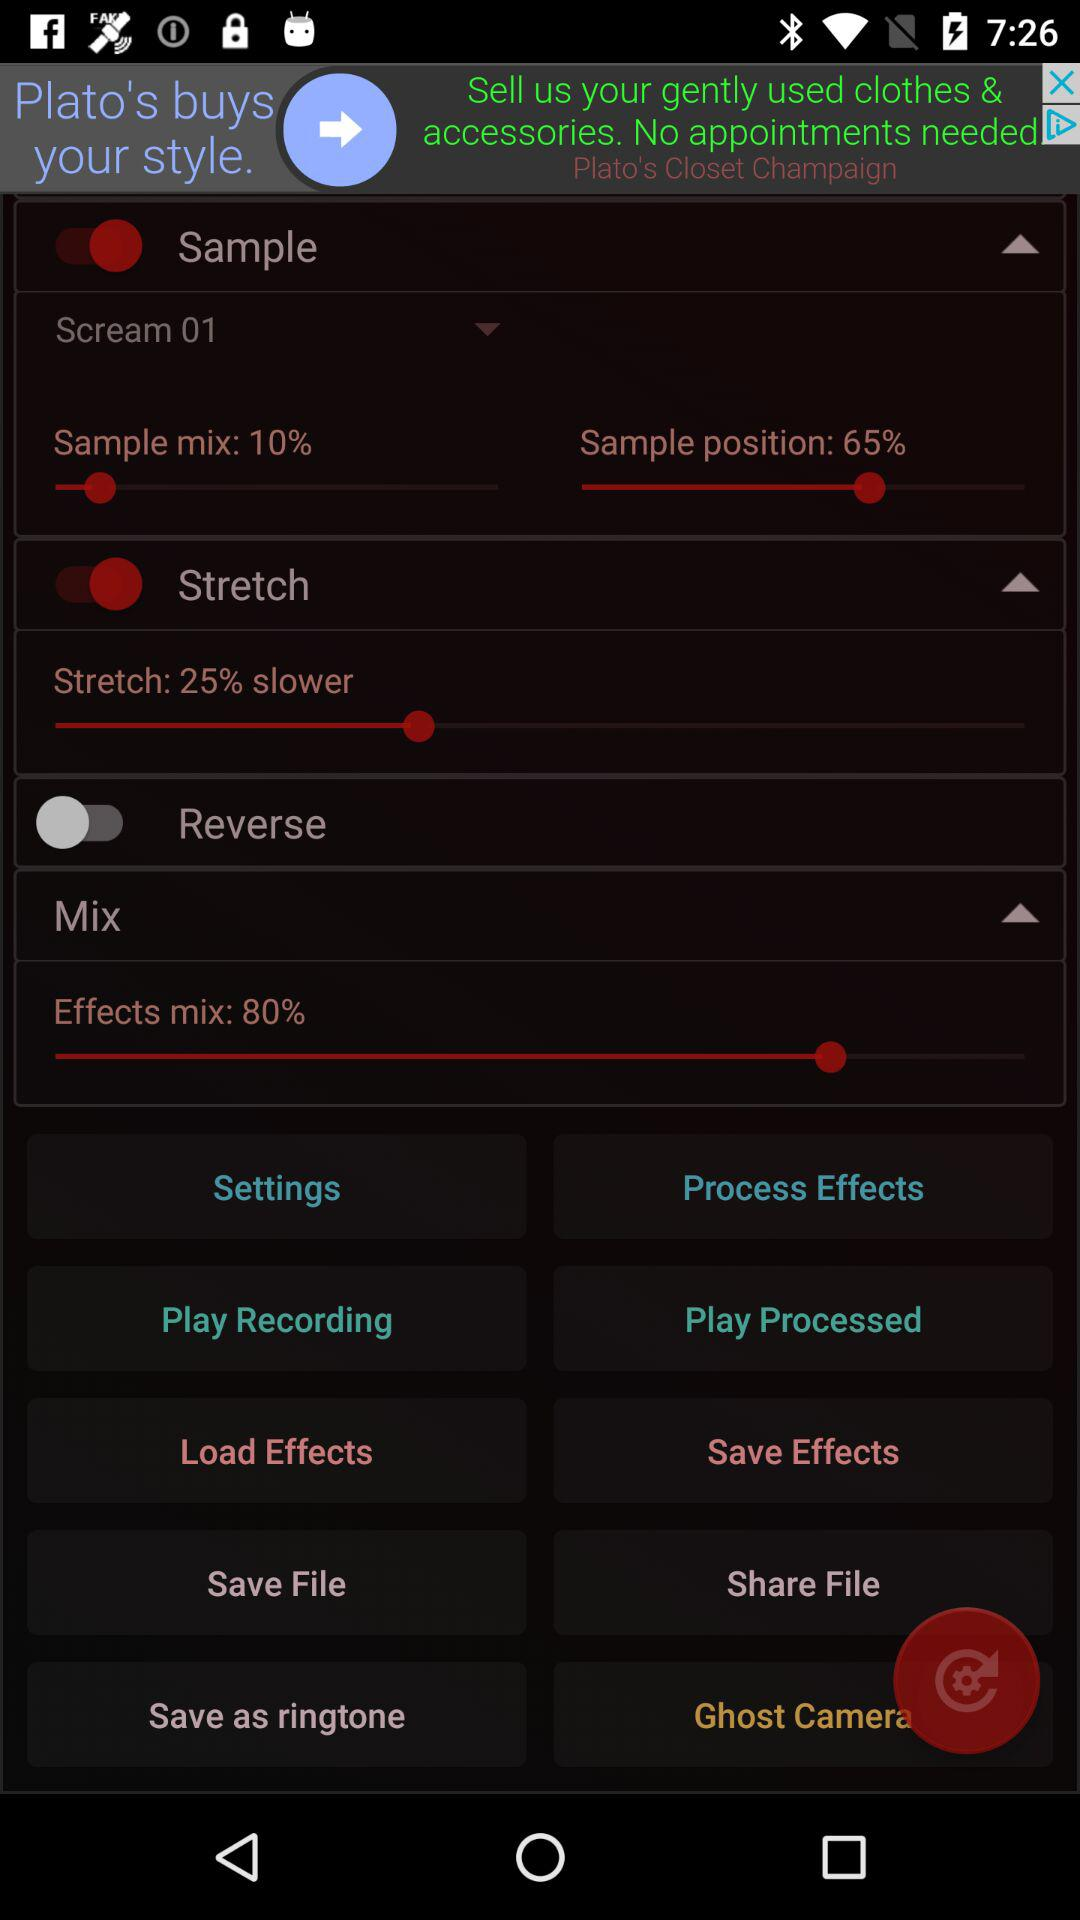What is the percentage of effects mix? The percentage of effects mix is 80. 